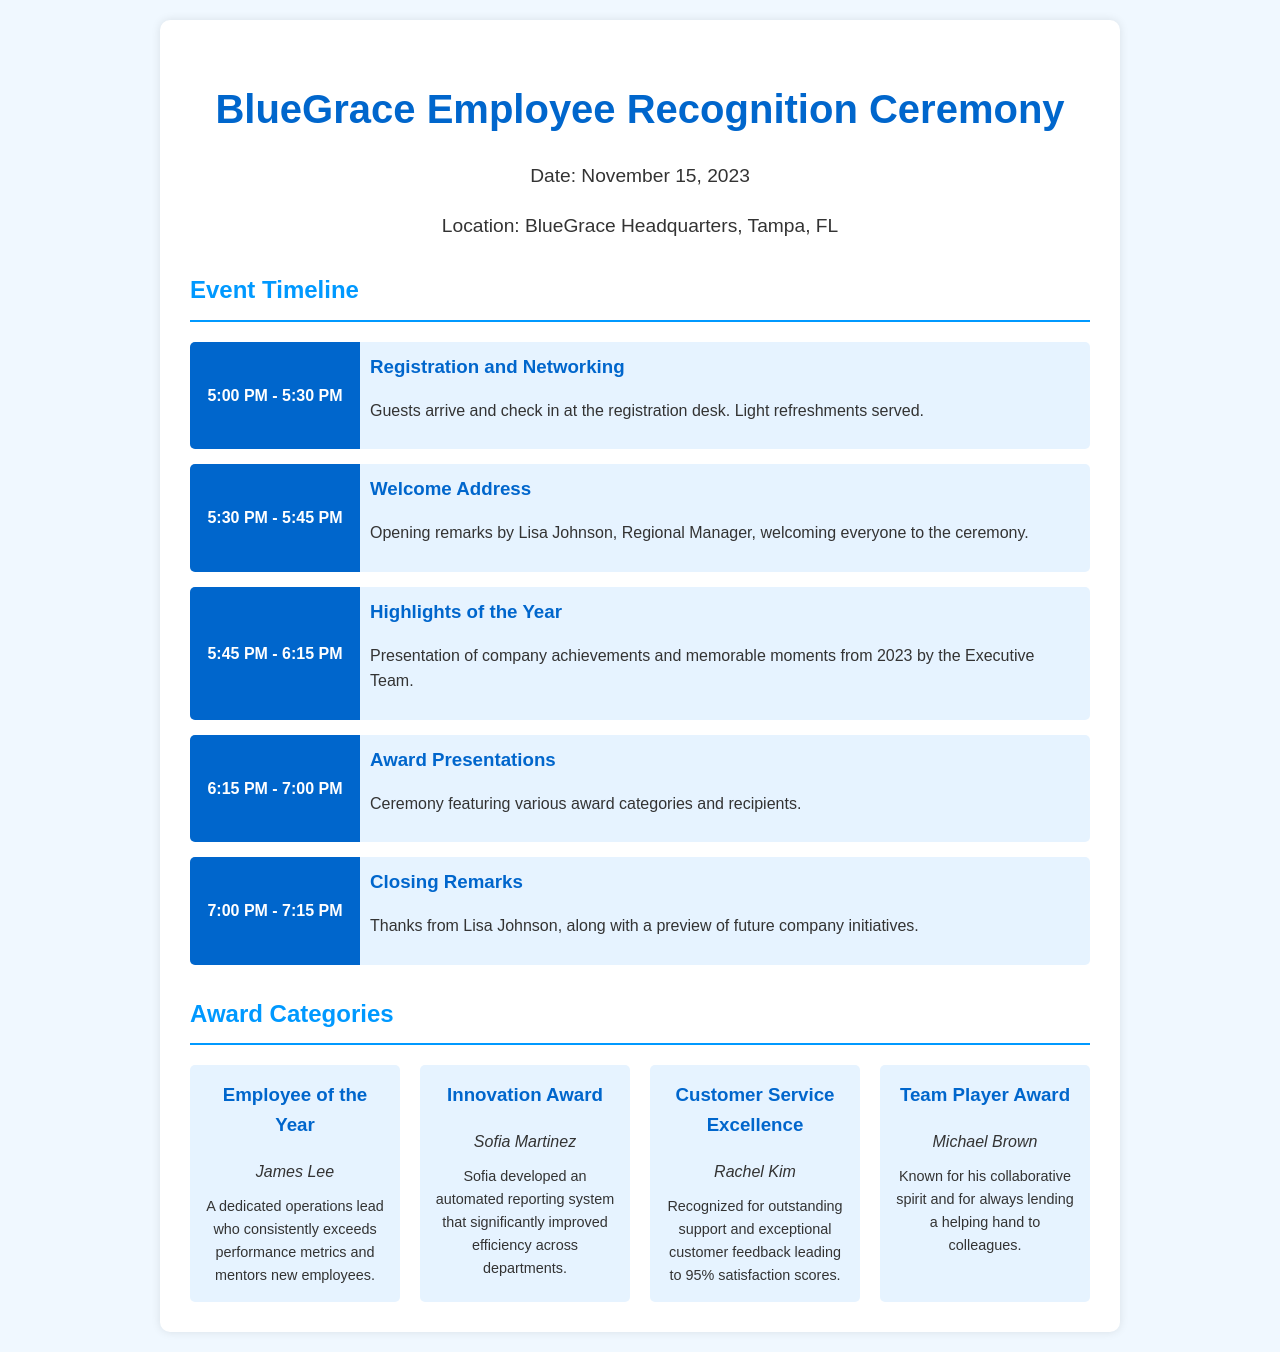What is the date of the ceremony? The specific date for the BlueGrace Employee Recognition Ceremony is provided in the event information section.
Answer: November 15, 2023 Who will give the welcome address? The document mentions who is giving the welcome address in the timeline of the event.
Answer: Lisa Johnson What award category did James Lee receive? The document lists the award categories along with the recipients, making it clear which award James Lee received.
Answer: Employee of the Year What time does registration and networking start? The timeline specifies the start time for registration and networking at the ceremony.
Answer: 5:00 PM Who is recognized for Customer Service Excellence? The awards section provides the recipient of the Customer Service Excellence award, highlighting their achievement.
Answer: Rachel Kim In what location is the ceremony held? The document reveals where the event will be taking place in the event information section.
Answer: BlueGrace Headquarters, Tampa, FL How long is the Award Presentations segment? The timeline in the document specifies the duration allocated for the Award Presentations.
Answer: 45 minutes What notable achievement did Sofia Martinez contribute? The description accompanying the Innovation Award highlights what Sofia Martinez developed for the company.
Answer: Automated reporting system 